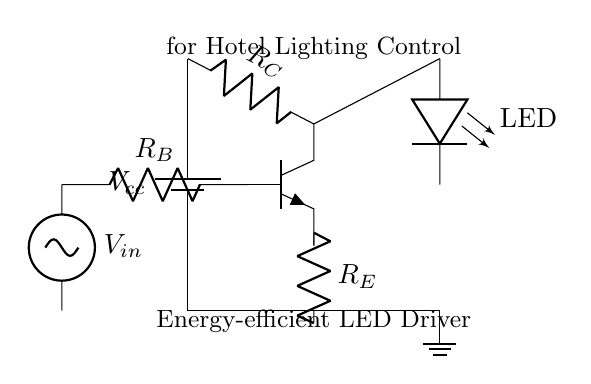What is the supply voltage in this circuit? The supply voltage is represented by Vcc in the circuit diagram and it's connected to the top node of the collector resistor, indicating the maximum voltage supplied to the circuit.
Answer: Vcc What type of transistor is used in this circuit? The circuit includes an npn transistor, which is indicated by the npn label on the transistor symbol in the diagram.
Answer: NPN What is the purpose of the resistor connected to the base of the transistor? The resistor labeled R_B connects to the base of the npn transistor, controlling the base current and thus regulating the transistor's operation.
Answer: Current control What is the function of the LED in this circuit? The LED connected at the output shows the light effect as a result of the amplified current flowing through it, serving as the lighting control element in the circuit.
Answer: Lighting indication How do the resistors R_C and R_E affect the transistor's operation? Resistor R_C influences the collector current and the voltage drop in the circuit, while R_E provides negative feedback, stabilizing the emitter current and overall performance of the transistor.
Answer: Stability and regulation What is the connection type of the ground in this circuit? The ground is shown at the bottom of the circuit diagram where all currents return; it is a common reference point for voltage measurements in the circuit.
Answer: Common reference 